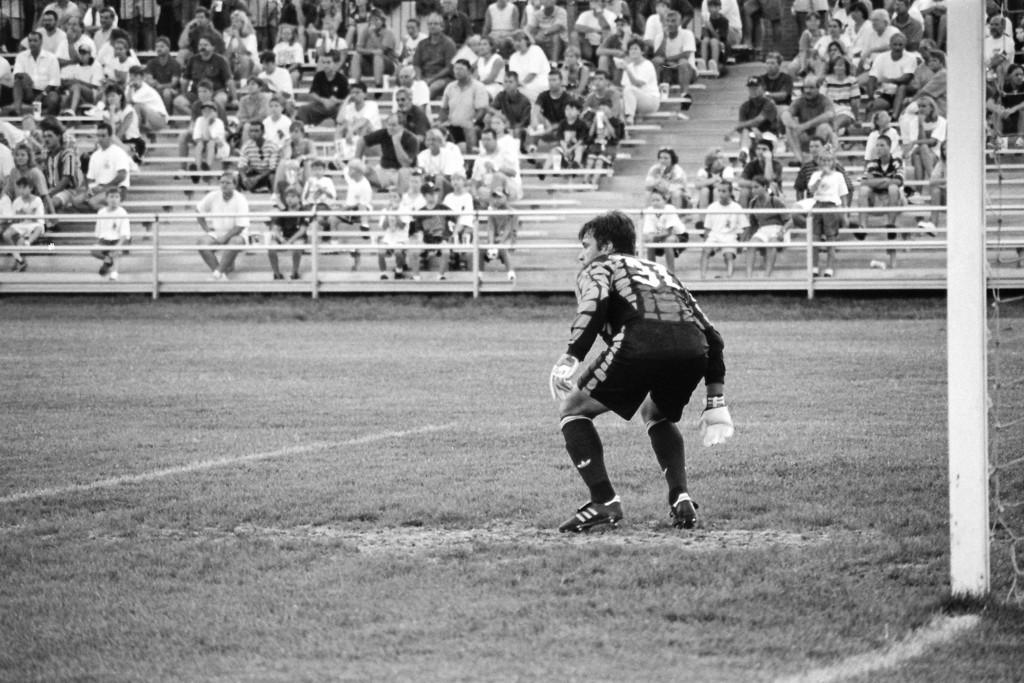What is the main subject of the image? There is a person standing in the image. What is the person's position in relation to the ground? The person is standing on the ground. What type of clothing is the person wearing? The person is wearing gloves. What can be seen in the background of the image? There is a fence and a group of people in the background of the image. Can you see any bees flying around the person in the image? There are no bees visible in the image. Is there a basin filled with blood near the person in the image? There is no basin or blood present in the image. 